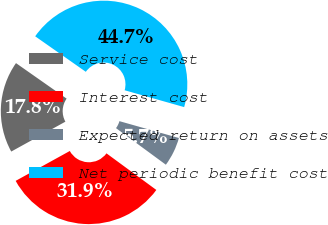Convert chart to OTSL. <chart><loc_0><loc_0><loc_500><loc_500><pie_chart><fcel>Service cost<fcel>Interest cost<fcel>Expected return on assets<fcel>Net periodic benefit cost<nl><fcel>17.76%<fcel>31.9%<fcel>5.69%<fcel>44.66%<nl></chart> 